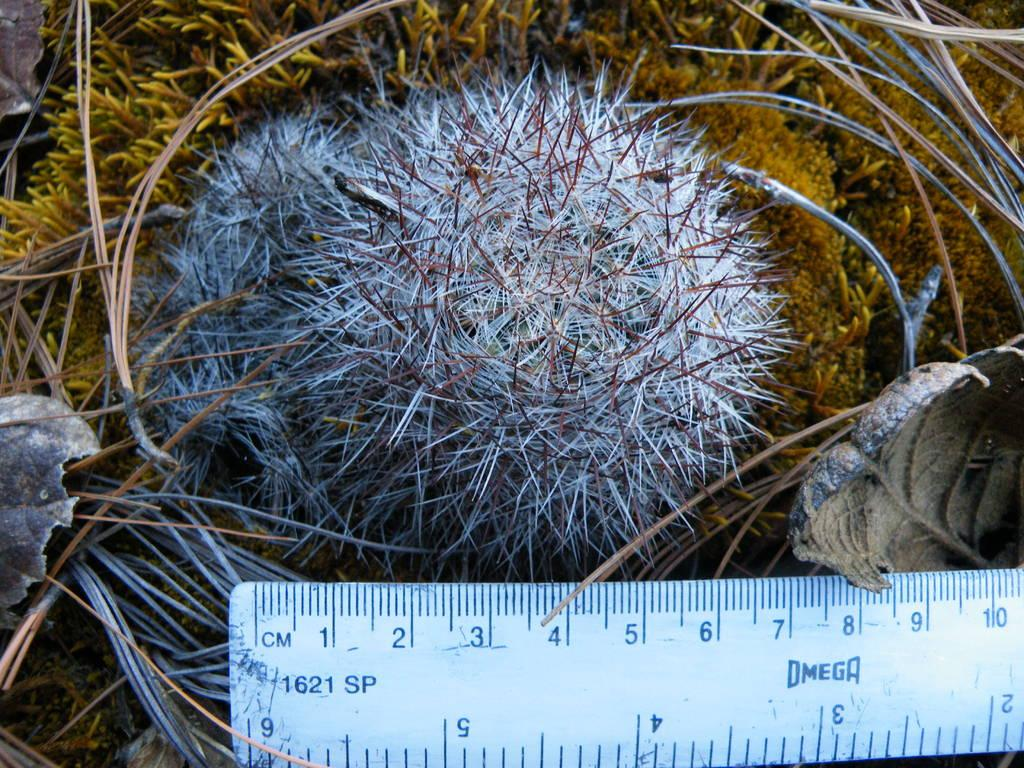<image>
Render a clear and concise summary of the photo. A blue ruler that measures in inches and centimeters with the logo for omega in the centerer. 